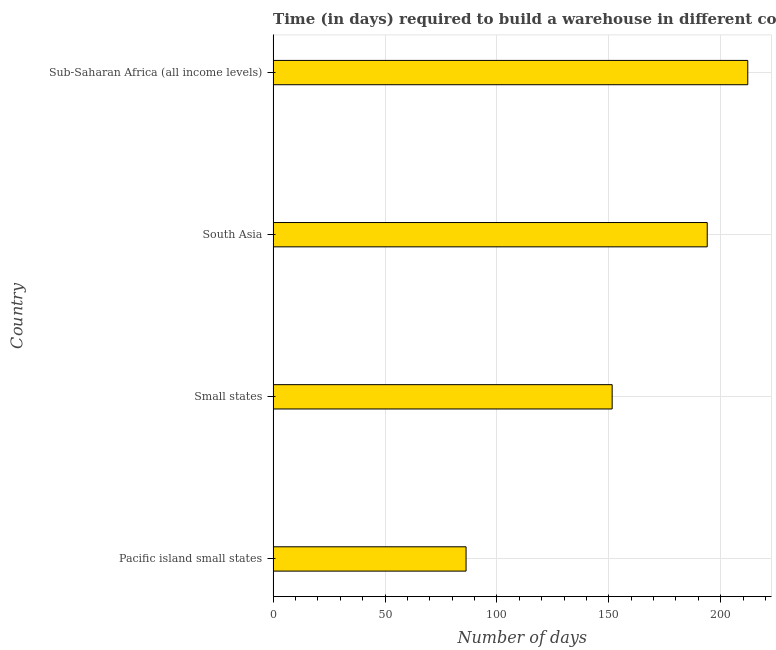Does the graph contain grids?
Offer a very short reply. Yes. What is the title of the graph?
Give a very brief answer. Time (in days) required to build a warehouse in different countries. What is the label or title of the X-axis?
Offer a terse response. Number of days. What is the time required to build a warehouse in Sub-Saharan Africa (all income levels)?
Make the answer very short. 212.11. Across all countries, what is the maximum time required to build a warehouse?
Keep it short and to the point. 212.11. Across all countries, what is the minimum time required to build a warehouse?
Provide a short and direct response. 86.22. In which country was the time required to build a warehouse maximum?
Your response must be concise. Sub-Saharan Africa (all income levels). In which country was the time required to build a warehouse minimum?
Make the answer very short. Pacific island small states. What is the sum of the time required to build a warehouse?
Provide a succinct answer. 643.85. What is the difference between the time required to build a warehouse in Pacific island small states and Sub-Saharan Africa (all income levels)?
Keep it short and to the point. -125.89. What is the average time required to build a warehouse per country?
Offer a terse response. 160.96. What is the median time required to build a warehouse?
Your response must be concise. 172.76. What is the ratio of the time required to build a warehouse in Small states to that in Sub-Saharan Africa (all income levels)?
Your answer should be very brief. 0.71. What is the difference between the highest and the second highest time required to build a warehouse?
Give a very brief answer. 18.11. Is the sum of the time required to build a warehouse in South Asia and Sub-Saharan Africa (all income levels) greater than the maximum time required to build a warehouse across all countries?
Your answer should be compact. Yes. What is the difference between the highest and the lowest time required to build a warehouse?
Make the answer very short. 125.89. How many bars are there?
Keep it short and to the point. 4. Are the values on the major ticks of X-axis written in scientific E-notation?
Offer a very short reply. No. What is the Number of days of Pacific island small states?
Your answer should be compact. 86.22. What is the Number of days of Small states?
Ensure brevity in your answer.  151.51. What is the Number of days of South Asia?
Provide a succinct answer. 194. What is the Number of days of Sub-Saharan Africa (all income levels)?
Your answer should be very brief. 212.11. What is the difference between the Number of days in Pacific island small states and Small states?
Provide a succinct answer. -65.29. What is the difference between the Number of days in Pacific island small states and South Asia?
Give a very brief answer. -107.78. What is the difference between the Number of days in Pacific island small states and Sub-Saharan Africa (all income levels)?
Your response must be concise. -125.89. What is the difference between the Number of days in Small states and South Asia?
Keep it short and to the point. -42.49. What is the difference between the Number of days in Small states and Sub-Saharan Africa (all income levels)?
Your answer should be very brief. -60.6. What is the difference between the Number of days in South Asia and Sub-Saharan Africa (all income levels)?
Ensure brevity in your answer.  -18.11. What is the ratio of the Number of days in Pacific island small states to that in Small states?
Your answer should be very brief. 0.57. What is the ratio of the Number of days in Pacific island small states to that in South Asia?
Your answer should be very brief. 0.44. What is the ratio of the Number of days in Pacific island small states to that in Sub-Saharan Africa (all income levels)?
Offer a very short reply. 0.41. What is the ratio of the Number of days in Small states to that in South Asia?
Offer a terse response. 0.78. What is the ratio of the Number of days in Small states to that in Sub-Saharan Africa (all income levels)?
Give a very brief answer. 0.71. What is the ratio of the Number of days in South Asia to that in Sub-Saharan Africa (all income levels)?
Your answer should be very brief. 0.92. 